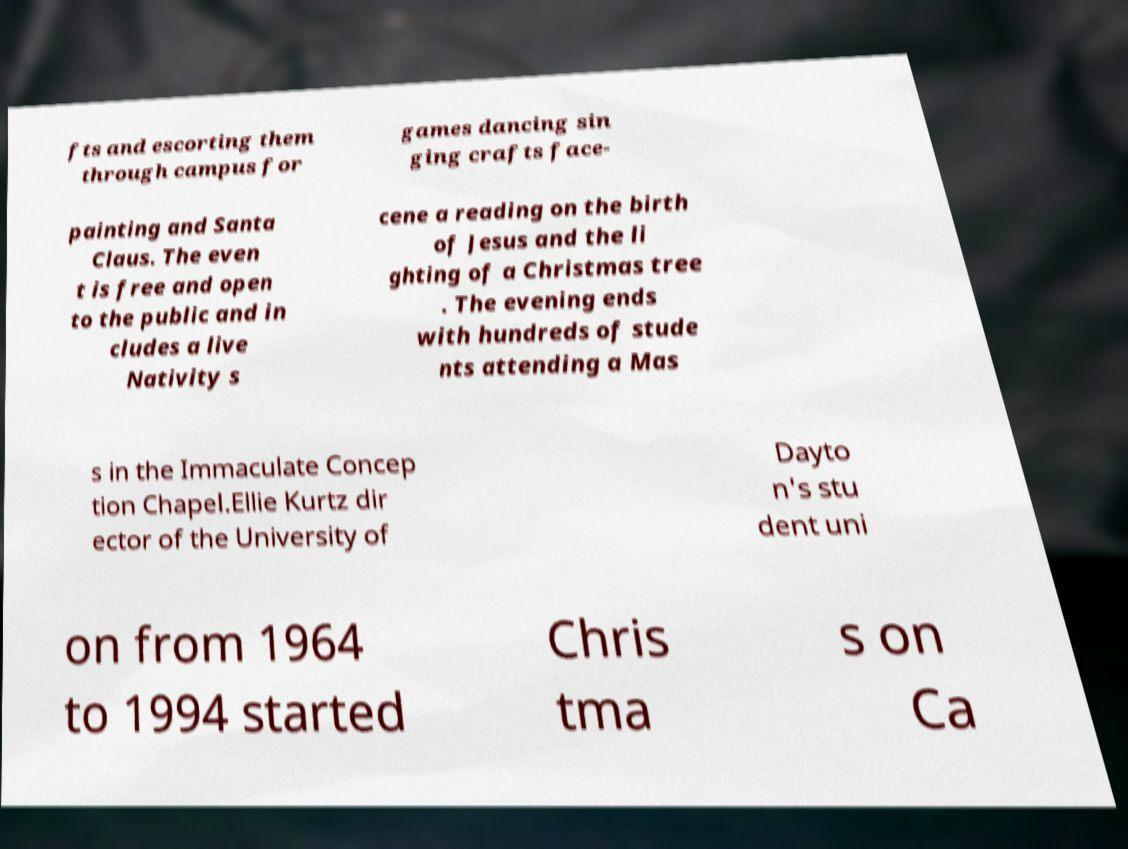Please identify and transcribe the text found in this image. fts and escorting them through campus for games dancing sin ging crafts face- painting and Santa Claus. The even t is free and open to the public and in cludes a live Nativity s cene a reading on the birth of Jesus and the li ghting of a Christmas tree . The evening ends with hundreds of stude nts attending a Mas s in the Immaculate Concep tion Chapel.Ellie Kurtz dir ector of the University of Dayto n's stu dent uni on from 1964 to 1994 started Chris tma s on Ca 